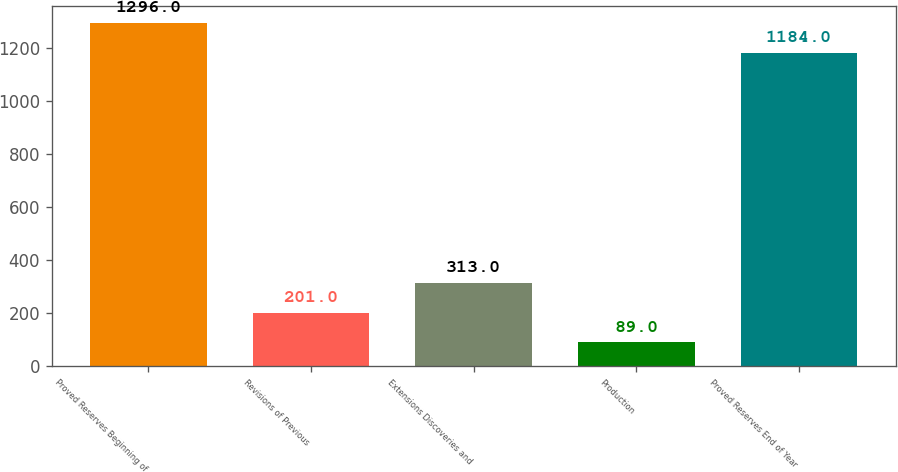Convert chart to OTSL. <chart><loc_0><loc_0><loc_500><loc_500><bar_chart><fcel>Proved Reserves Beginning of<fcel>Revisions of Previous<fcel>Extensions Discoveries and<fcel>Production<fcel>Proved Reserves End of Year<nl><fcel>1296<fcel>201<fcel>313<fcel>89<fcel>1184<nl></chart> 